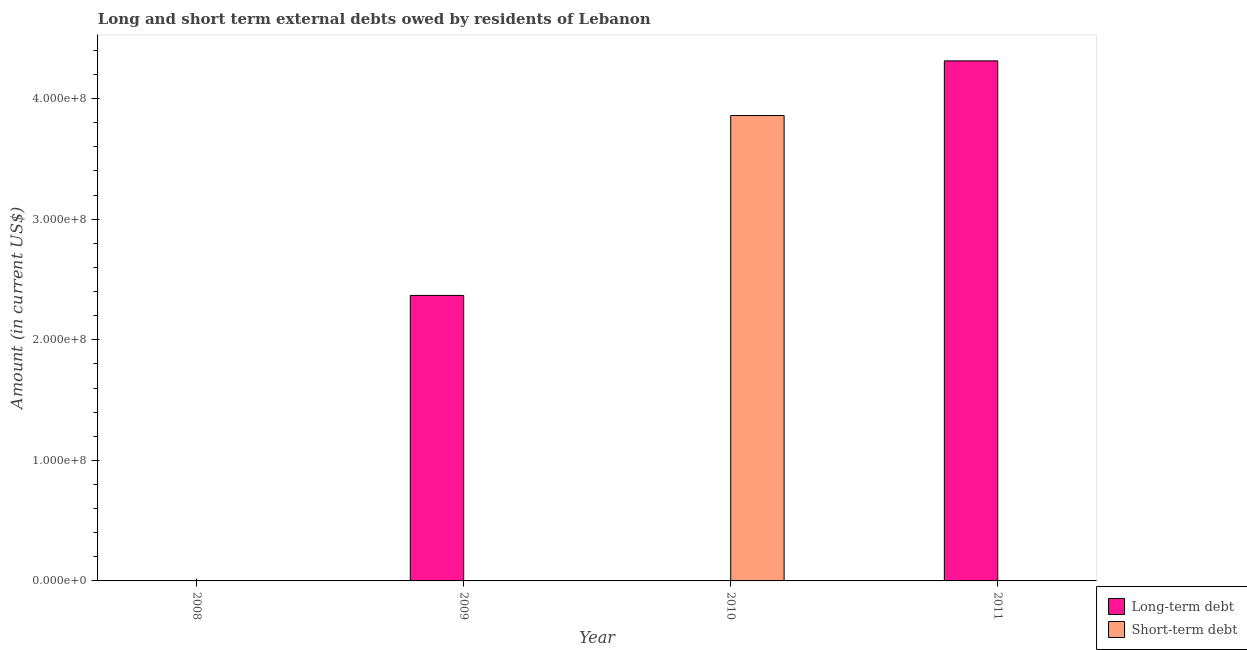How many different coloured bars are there?
Offer a very short reply. 2. Are the number of bars per tick equal to the number of legend labels?
Offer a terse response. No. Are the number of bars on each tick of the X-axis equal?
Give a very brief answer. No. How many bars are there on the 4th tick from the left?
Your answer should be very brief. 1. How many bars are there on the 1st tick from the right?
Your answer should be compact. 1. What is the label of the 1st group of bars from the left?
Provide a succinct answer. 2008. In how many cases, is the number of bars for a given year not equal to the number of legend labels?
Offer a very short reply. 4. What is the short-term debts owed by residents in 2010?
Provide a succinct answer. 3.86e+08. Across all years, what is the maximum short-term debts owed by residents?
Ensure brevity in your answer.  3.86e+08. What is the total long-term debts owed by residents in the graph?
Your answer should be compact. 6.68e+08. What is the difference between the long-term debts owed by residents in 2009 and that in 2011?
Keep it short and to the point. -1.95e+08. What is the difference between the long-term debts owed by residents in 2009 and the short-term debts owed by residents in 2008?
Keep it short and to the point. 2.37e+08. What is the average long-term debts owed by residents per year?
Offer a very short reply. 1.67e+08. In the year 2009, what is the difference between the long-term debts owed by residents and short-term debts owed by residents?
Offer a very short reply. 0. In how many years, is the short-term debts owed by residents greater than 60000000 US$?
Ensure brevity in your answer.  1. What is the difference between the highest and the lowest short-term debts owed by residents?
Give a very brief answer. 3.86e+08. In how many years, is the short-term debts owed by residents greater than the average short-term debts owed by residents taken over all years?
Give a very brief answer. 1. Are all the bars in the graph horizontal?
Offer a very short reply. No. Are the values on the major ticks of Y-axis written in scientific E-notation?
Provide a succinct answer. Yes. Does the graph contain any zero values?
Provide a short and direct response. Yes. Does the graph contain grids?
Offer a terse response. No. How many legend labels are there?
Keep it short and to the point. 2. What is the title of the graph?
Offer a very short reply. Long and short term external debts owed by residents of Lebanon. Does "Non-resident workers" appear as one of the legend labels in the graph?
Keep it short and to the point. No. What is the label or title of the X-axis?
Provide a short and direct response. Year. What is the label or title of the Y-axis?
Give a very brief answer. Amount (in current US$). What is the Amount (in current US$) of Long-term debt in 2008?
Provide a succinct answer. 0. What is the Amount (in current US$) of Short-term debt in 2008?
Offer a very short reply. 0. What is the Amount (in current US$) of Long-term debt in 2009?
Your response must be concise. 2.37e+08. What is the Amount (in current US$) of Long-term debt in 2010?
Your response must be concise. 0. What is the Amount (in current US$) of Short-term debt in 2010?
Provide a succinct answer. 3.86e+08. What is the Amount (in current US$) of Long-term debt in 2011?
Offer a very short reply. 4.31e+08. Across all years, what is the maximum Amount (in current US$) of Long-term debt?
Give a very brief answer. 4.31e+08. Across all years, what is the maximum Amount (in current US$) of Short-term debt?
Your answer should be very brief. 3.86e+08. Across all years, what is the minimum Amount (in current US$) of Long-term debt?
Offer a very short reply. 0. What is the total Amount (in current US$) of Long-term debt in the graph?
Give a very brief answer. 6.68e+08. What is the total Amount (in current US$) in Short-term debt in the graph?
Your answer should be compact. 3.86e+08. What is the difference between the Amount (in current US$) of Long-term debt in 2009 and that in 2011?
Make the answer very short. -1.95e+08. What is the difference between the Amount (in current US$) of Long-term debt in 2009 and the Amount (in current US$) of Short-term debt in 2010?
Keep it short and to the point. -1.49e+08. What is the average Amount (in current US$) of Long-term debt per year?
Keep it short and to the point. 1.67e+08. What is the average Amount (in current US$) in Short-term debt per year?
Make the answer very short. 9.65e+07. What is the ratio of the Amount (in current US$) of Long-term debt in 2009 to that in 2011?
Provide a short and direct response. 0.55. What is the difference between the highest and the lowest Amount (in current US$) of Long-term debt?
Provide a short and direct response. 4.31e+08. What is the difference between the highest and the lowest Amount (in current US$) in Short-term debt?
Keep it short and to the point. 3.86e+08. 